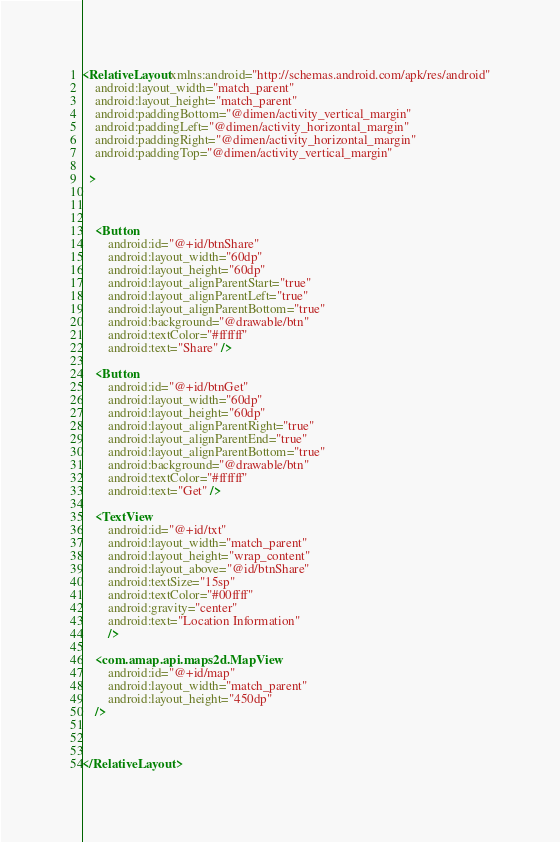<code> <loc_0><loc_0><loc_500><loc_500><_XML_><RelativeLayout xmlns:android="http://schemas.android.com/apk/res/android"
    android:layout_width="match_parent"
    android:layout_height="match_parent"
    android:paddingBottom="@dimen/activity_vertical_margin"
    android:paddingLeft="@dimen/activity_horizontal_margin"
    android:paddingRight="@dimen/activity_horizontal_margin"
    android:paddingTop="@dimen/activity_vertical_margin"
    
  >
    
    
    
    <Button
        android:id="@+id/btnShare"
        android:layout_width="60dp"
        android:layout_height="60dp"
        android:layout_alignParentStart="true"
        android:layout_alignParentLeft="true"
        android:layout_alignParentBottom="true"
        android:background="@drawable/btn"
        android:textColor="#ffffff"
        android:text="Share" />

    <Button
        android:id="@+id/btnGet"
        android:layout_width="60dp"
        android:layout_height="60dp"
        android:layout_alignParentRight="true"
        android:layout_alignParentEnd="true"
        android:layout_alignParentBottom="true"
        android:background="@drawable/btn"
        android:textColor="#ffffff"
        android:text="Get" />
    
    <TextView 
        android:id="@+id/txt"
        android:layout_width="match_parent"
        android:layout_height="wrap_content"
        android:layout_above="@id/btnShare"
        android:textSize="15sp"
        android:textColor="#00ffff"
        android:gravity="center"
        android:text="Location Information"
        />

    <com.amap.api.maps2d.MapView
	    android:id="@+id/map"
	    android:layout_width="match_parent"
	    android:layout_height="450dp"
    />

    
    
</RelativeLayout>
</code> 